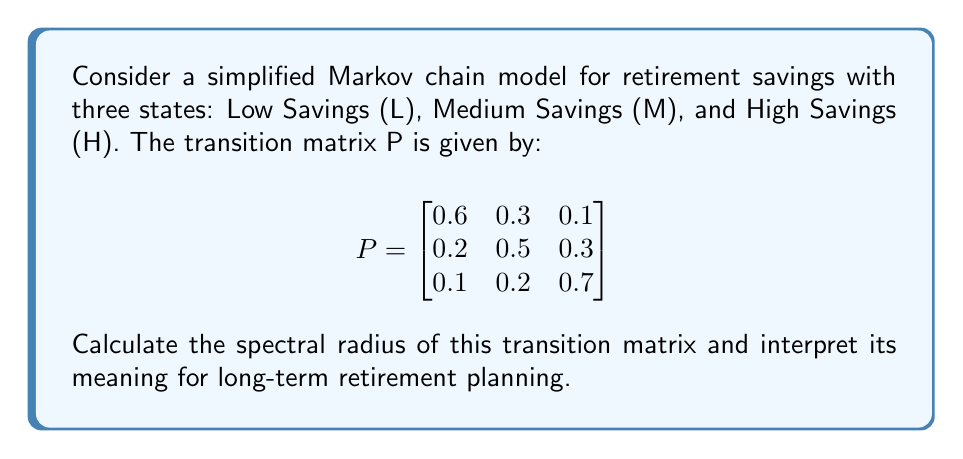Provide a solution to this math problem. To find the spectral radius of the transition matrix P, we need to follow these steps:

1) First, calculate the characteristic polynomial of P:
   $\det(P - \lambda I) = 0$
   
   $$\begin{vmatrix}
   0.6-\lambda & 0.3 & 0.1 \\
   0.2 & 0.5-\lambda & 0.3 \\
   0.1 & 0.2 & 0.7-\lambda
   \end{vmatrix} = 0$$

2) Expanding the determinant:
   $(0.6-\lambda)[(0.5-\lambda)(0.7-\lambda)-0.06] - 0.3[0.2(0.7-\lambda)-0.03] + 0.1[0.2(0.5-\lambda)-0.06] = 0$

3) Simplifying:
   $-\lambda^3 + 1.8\lambda^2 - 0.83\lambda + 0.1 = 0$

4) The roots of this polynomial are the eigenvalues of P. Using a numerical method or a computer algebra system, we find the roots:
   $\lambda_1 \approx 1$
   $\lambda_2 \approx 0.5$
   $\lambda_3 \approx 0.3$

5) The spectral radius is the largest absolute value among the eigenvalues:
   $\rho(P) = \max(|\lambda_1|, |\lambda_2|, |\lambda_3|) = 1$

6) Interpretation: The spectral radius of 1 indicates that the Markov chain is regular and has a unique stationary distribution. In the context of retirement planning, this means that regardless of the initial savings state, there is a stable long-term distribution of savings levels that the system will converge to over time.
Answer: $\rho(P) = 1$ 